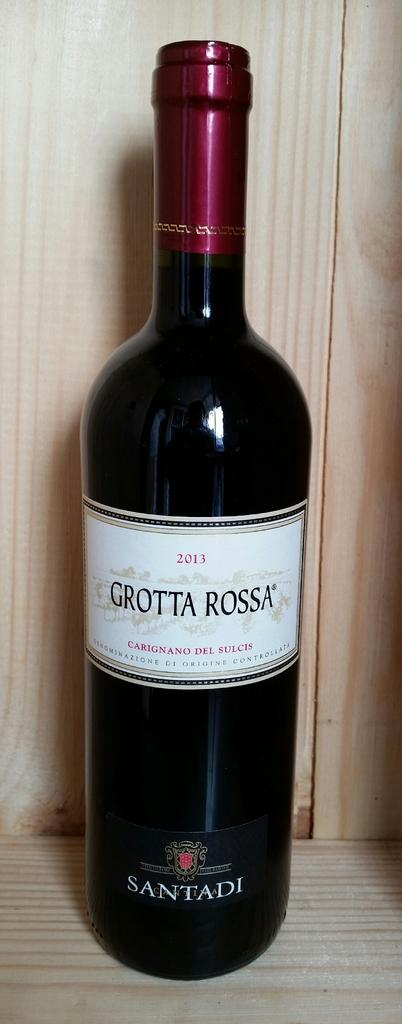<image>
Render a clear and concise summary of the photo. A bottle of Grotta Rossa from 2013 sits in a wooden crate. 